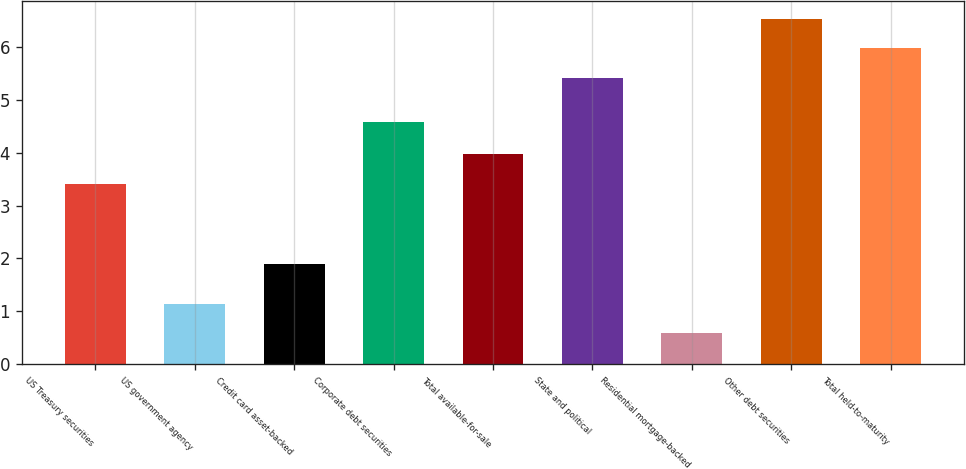<chart> <loc_0><loc_0><loc_500><loc_500><bar_chart><fcel>US Treasury securities<fcel>US government agency<fcel>Credit card asset-backed<fcel>Corporate debt securities<fcel>Total available-for-sale<fcel>State and political<fcel>Residential mortgage-backed<fcel>Other debt securities<fcel>Total held-to-maturity<nl><fcel>3.41<fcel>1.14<fcel>1.9<fcel>4.58<fcel>3.97<fcel>5.42<fcel>0.58<fcel>6.54<fcel>5.98<nl></chart> 